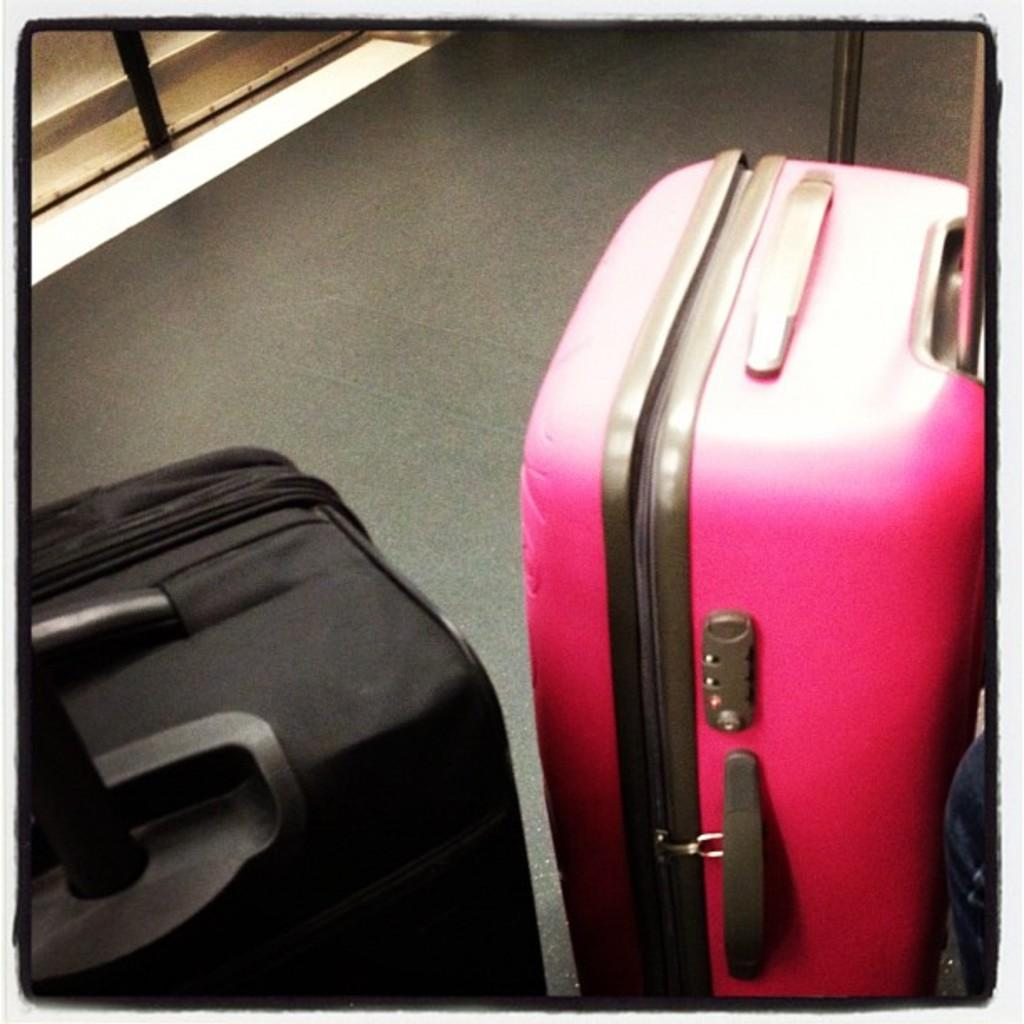What songs is the finger playing on the train in the image? There is no train or finger playing songs in the image, as no specific facts about the image were provided. 